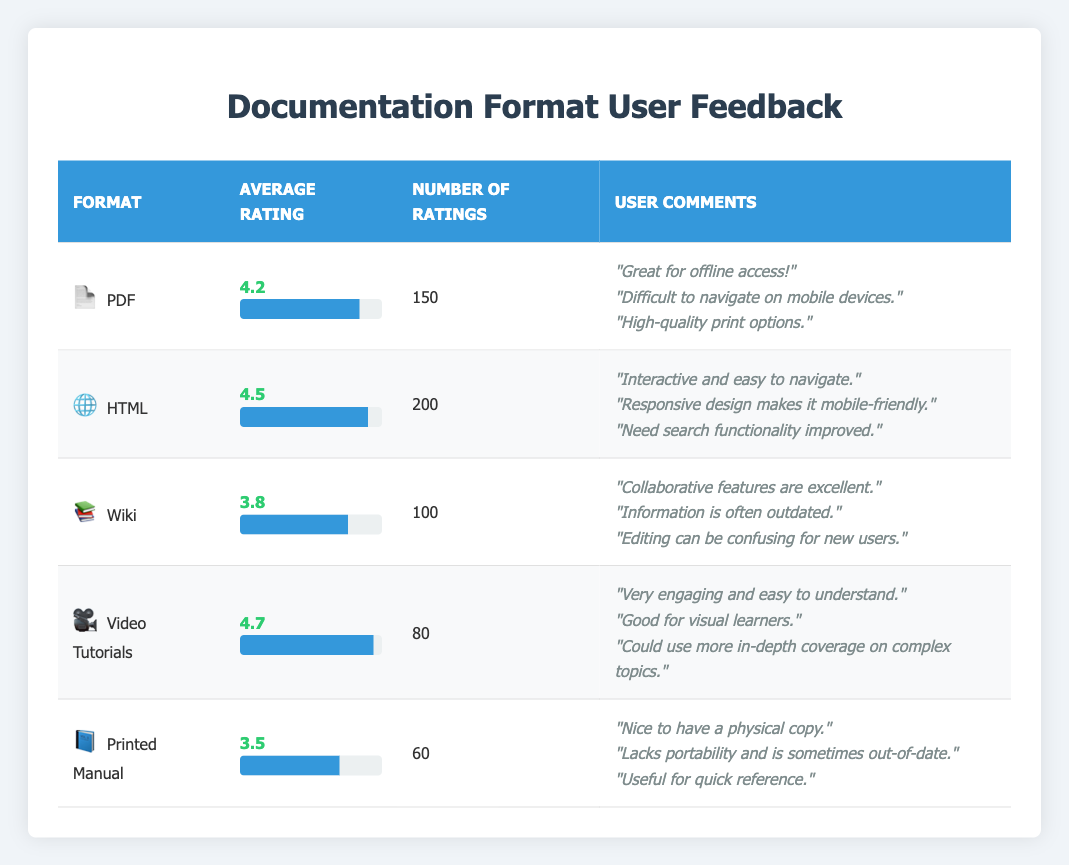What is the highest average rating among the documentation formats? The highest average rating can be found by comparing the average ratings of all formats listed. The ratings are: PDF (4.2), HTML (4.5), Wiki (3.8), Video Tutorials (4.7), and Printed Manual (3.5). Among these, Video Tutorials has the highest rating of 4.7.
Answer: 4.7 How many total ratings were received for all documentation formats? To find the total ratings, we need to sum the number of ratings for each format. The numbers are: PDF (150), HTML (200), Wiki (100), Video Tutorials (80), and Printed Manual (60). Adding these gives 150 + 200 + 100 + 80 + 60 = 590 total ratings.
Answer: 590 Is the average rating for the Wiki format above 4.0? The average rating for the Wiki format is 3.8, which is below 4.0. Therefore, the statement is false.
Answer: No Which documentation format received the least number of ratings? The least number of ratings can be determined by comparing the number of ratings for each format: PDF (150), HTML (200), Wiki (100), Video Tutorials (80), and Printed Manual (60). Printed Manual has the lowest count at 60 ratings.
Answer: Printed Manual What is the average rating of the documentation formats that are not printed manuals? To calculate this, we sum the average ratings of all formats except Printed Manual: PDF (4.2), HTML (4.5), Wiki (3.8), and Video Tutorials (4.7). The total is 4.2 + 4.5 + 3.8 + 4.7 = 17.2, and there are 4 formats, so the average is 17.2 / 4 = 4.3.
Answer: 4.3 Do more users prefer HTML over PDF based on the average ratings? The average rating for HTML is 4.5 and for PDF is 4.2. Since 4.5 is greater than 4.2, this indicates that more users prefer HTML based on the average ratings, making the statement true.
Answer: Yes What percentage of total ratings does Video Tutorials represent? First, find the number of ratings for Video Tutorials, which is 80. Then divide by the total ratings calculated earlier, which is 590. The percentage is (80 / 590) * 100 = approximately 13.56%.
Answer: 13.56% What are the user comments for the HTML documentation format? The user comments for the HTML format are: "Interactive and easy to navigate.", "Responsive design makes it mobile-friendly.", and "Need search functionality improved." This can be confirmed directly from the data.
Answer: "Interactive and easy to navigate.", "Responsive design makes it mobile-friendly.", "Need search functionality improved." 